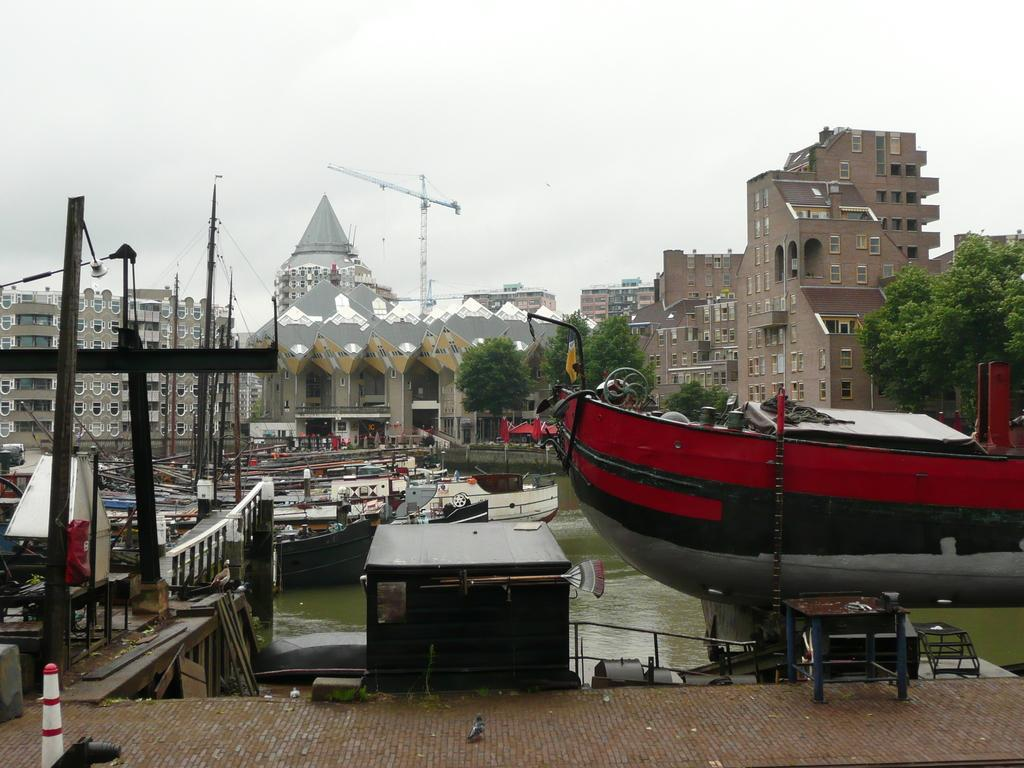What can be seen on the water in the image? There are boats on the water in the image. What type of structures are present in the image? There are fences, a platform, a table, and buildings with windows in the image. What type of vegetation is visible in the image? There are trees in the image. What type of machinery is present in the image? There is a crane in the image. What else can be seen in the image? There are some objects in the image. What is visible in the background of the image? The sky is visible in the background of the image. How many jellyfish are swimming in the water in the image? There are no jellyfish present in the image; it features boats on the water. What type of ground is visible in the image? The image does not show any ground; it primarily features water, boats, and structures. 